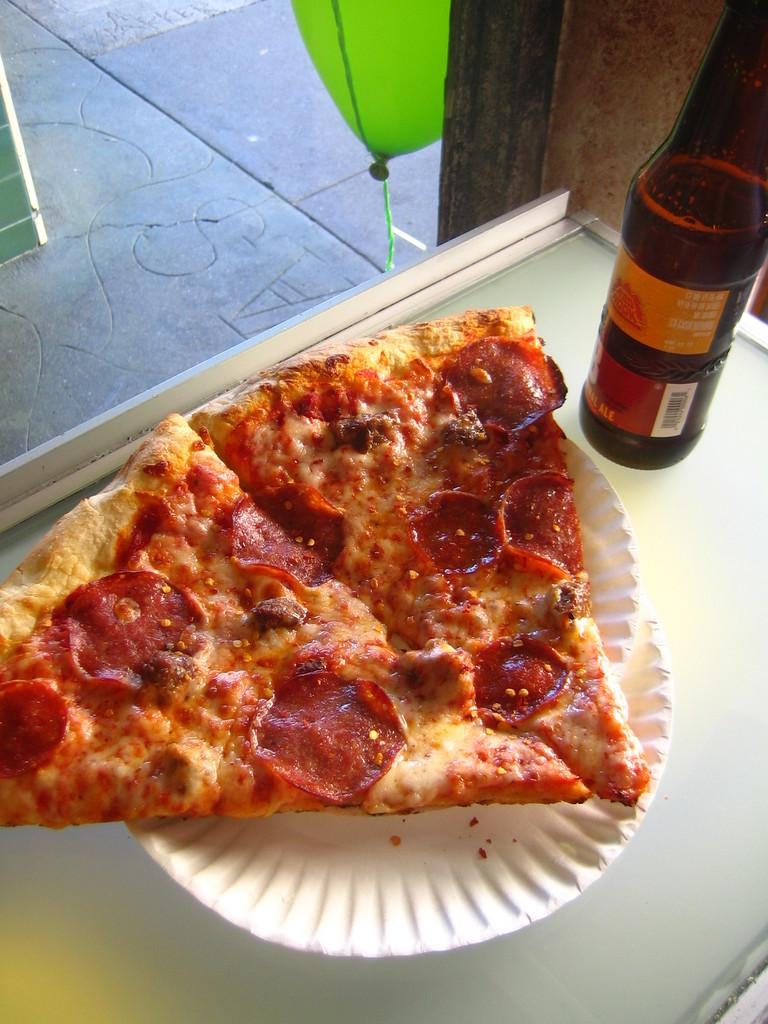What object can be seen on the table in the image? There is a bottle on the table in the image. What type of food is present on the table? There are two pizza slices on a paper plate on the table. What can be seen in the background of the image? There is a balloon in the background, and the floor is also visible. What type of shirt is the doctor wearing at the baby's birth in the image? There is no shirt, doctor, or baby's birth present in the image. 